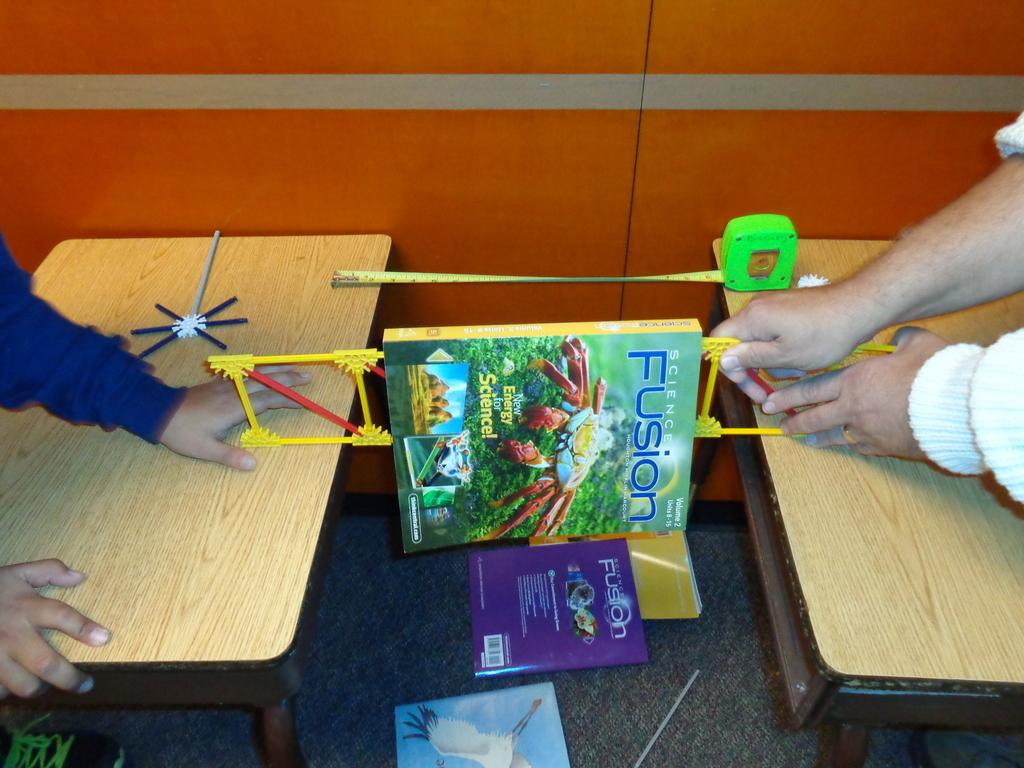Provide a one-sentence caption for the provided image. A book that is called Science Fusion and has a crab on it. 